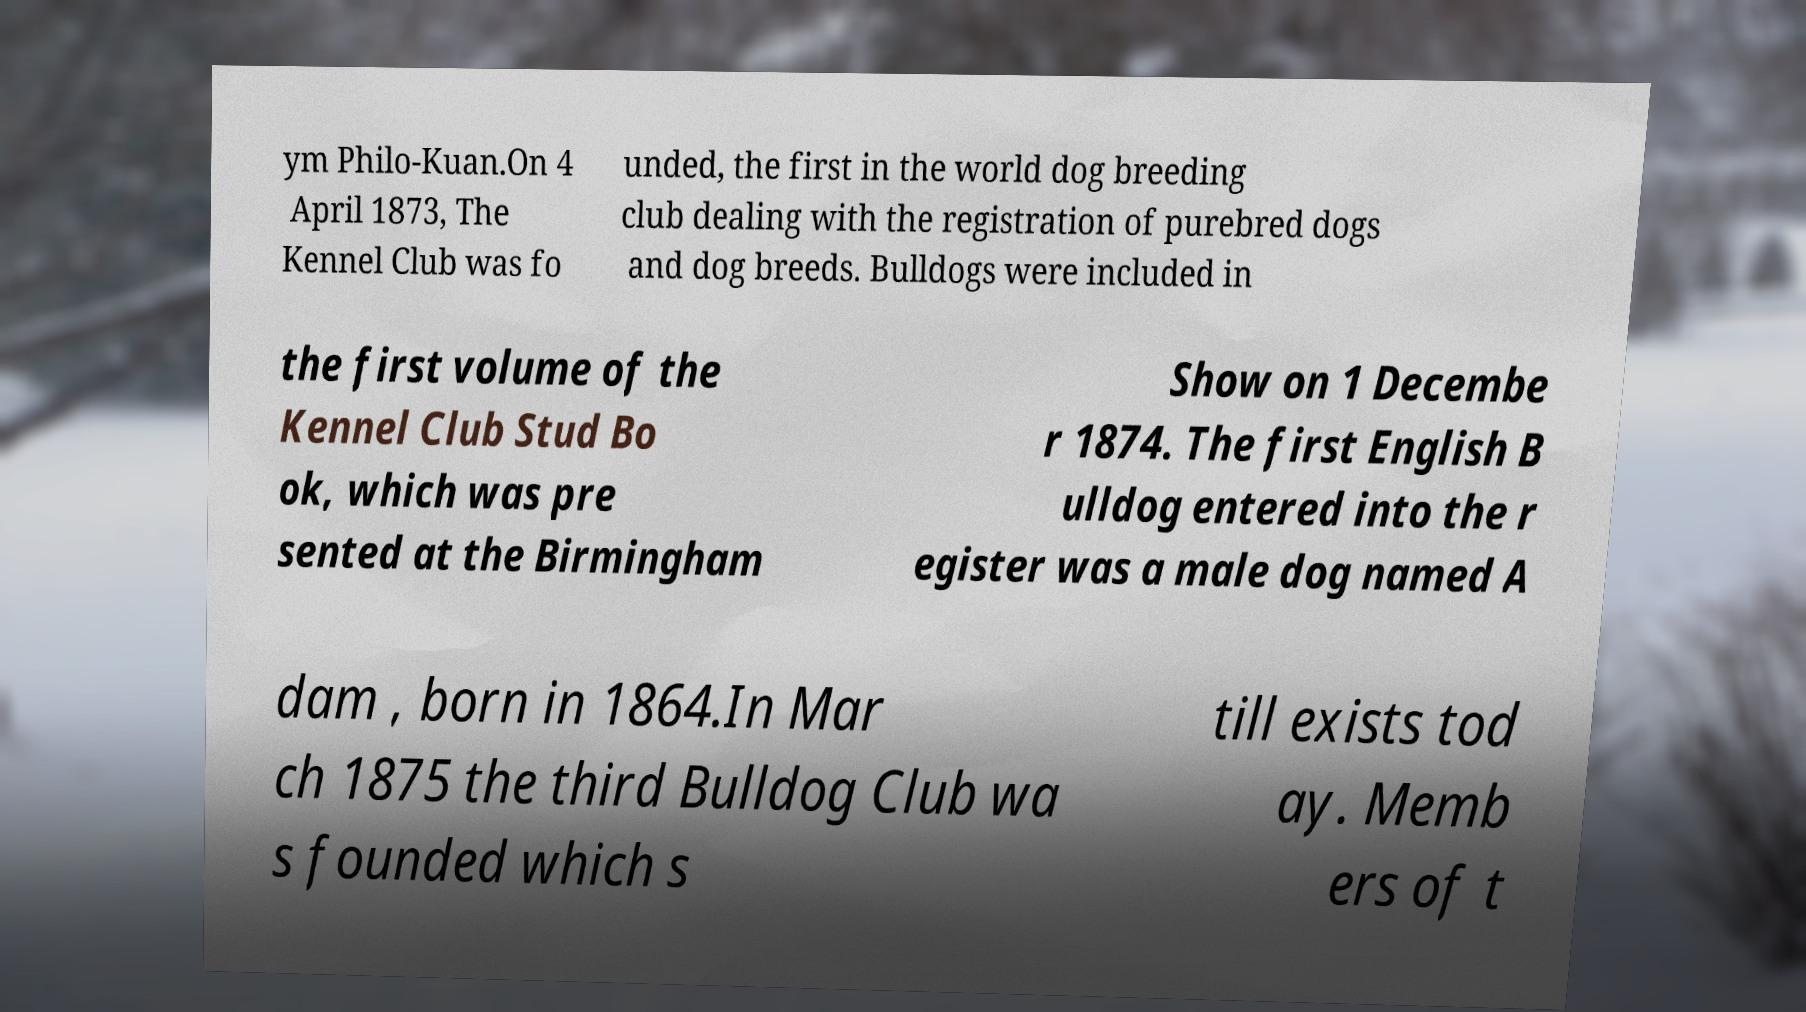Could you assist in decoding the text presented in this image and type it out clearly? ym Philo-Kuan.On 4 April 1873, The Kennel Club was fo unded, the first in the world dog breeding club dealing with the registration of purebred dogs and dog breeds. Bulldogs were included in the first volume of the Kennel Club Stud Bo ok, which was pre sented at the Birmingham Show on 1 Decembe r 1874. The first English B ulldog entered into the r egister was a male dog named A dam , born in 1864.In Mar ch 1875 the third Bulldog Club wa s founded which s till exists tod ay. Memb ers of t 